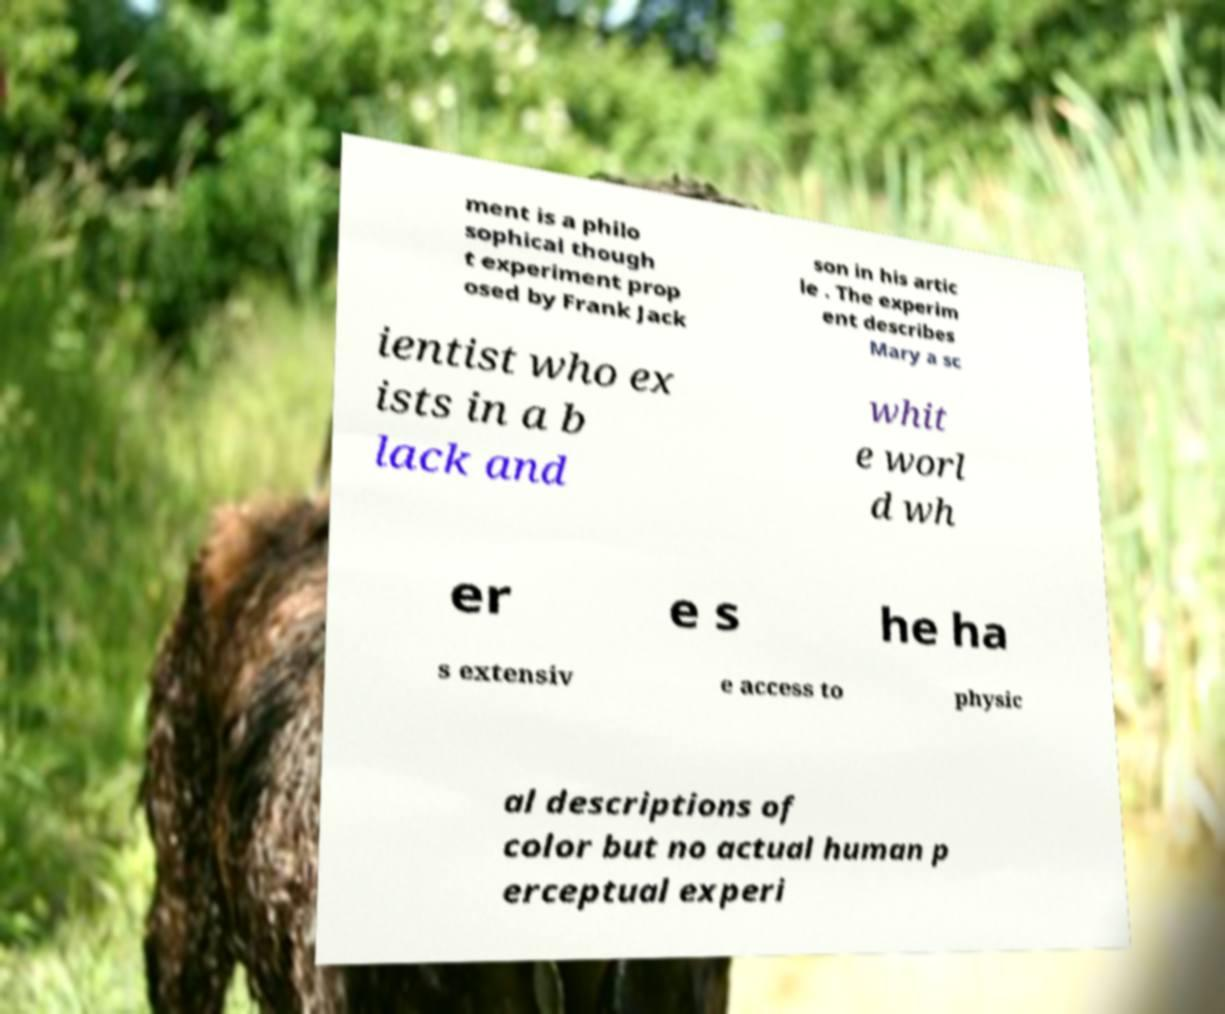Could you assist in decoding the text presented in this image and type it out clearly? ment is a philo sophical though t experiment prop osed by Frank Jack son in his artic le . The experim ent describes Mary a sc ientist who ex ists in a b lack and whit e worl d wh er e s he ha s extensiv e access to physic al descriptions of color but no actual human p erceptual experi 